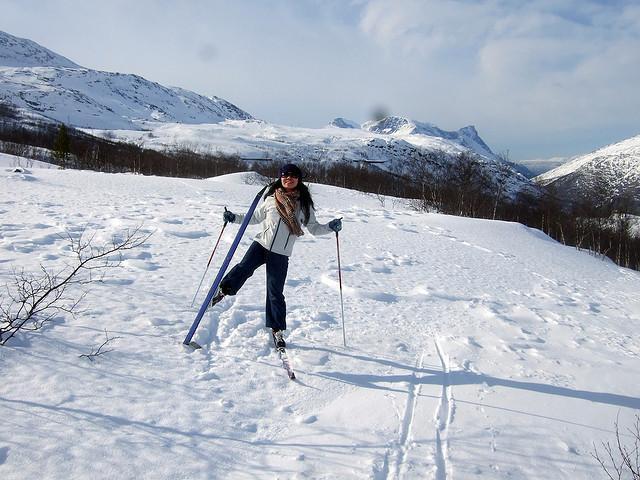How many people are in this photo?
Give a very brief answer. 1. 